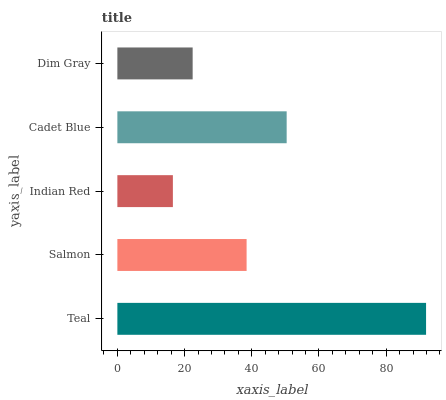Is Indian Red the minimum?
Answer yes or no. Yes. Is Teal the maximum?
Answer yes or no. Yes. Is Salmon the minimum?
Answer yes or no. No. Is Salmon the maximum?
Answer yes or no. No. Is Teal greater than Salmon?
Answer yes or no. Yes. Is Salmon less than Teal?
Answer yes or no. Yes. Is Salmon greater than Teal?
Answer yes or no. No. Is Teal less than Salmon?
Answer yes or no. No. Is Salmon the high median?
Answer yes or no. Yes. Is Salmon the low median?
Answer yes or no. Yes. Is Dim Gray the high median?
Answer yes or no. No. Is Teal the low median?
Answer yes or no. No. 